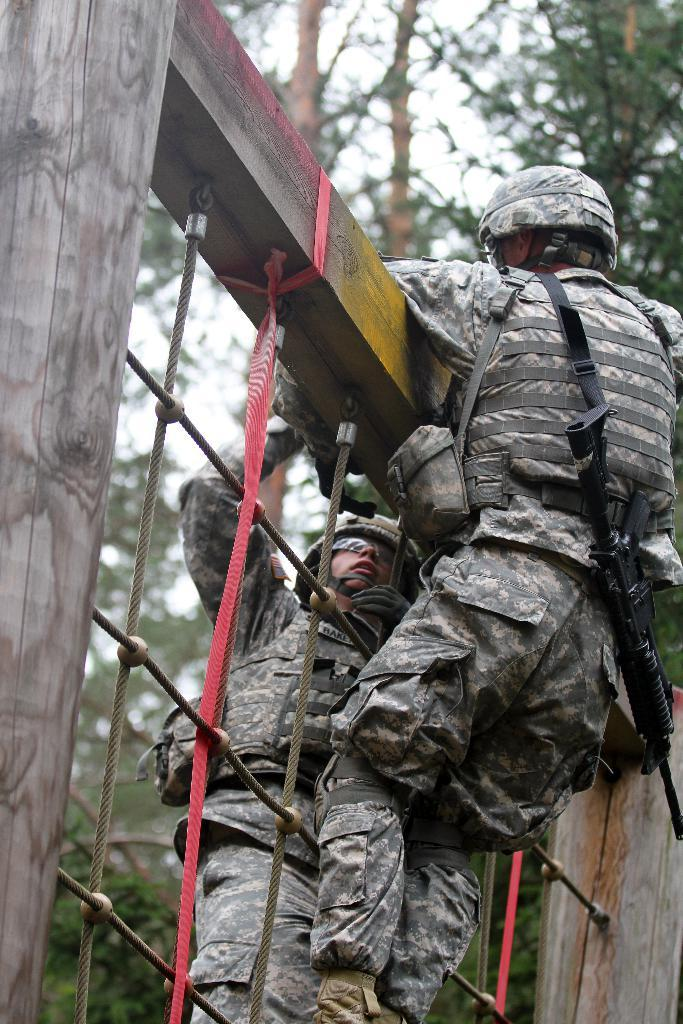How many people are in the image? There are two people in the image. What are the people doing in the image? The people are climbing ropes. What are the ropes attached to? The ropes are attached to a wooden frame. What protective gear are the people wearing? The people are wearing helmets and glasses. What else can be seen in the image? The people have weapons, and there are trees in the background of the image. What type of pin is holding the birthday cake in the image? There is no birthday cake or pin present in the image. How many legs does the person on the left have in the image? The people in the image have two legs each, as they are not depicted with any injuries or amputations. 